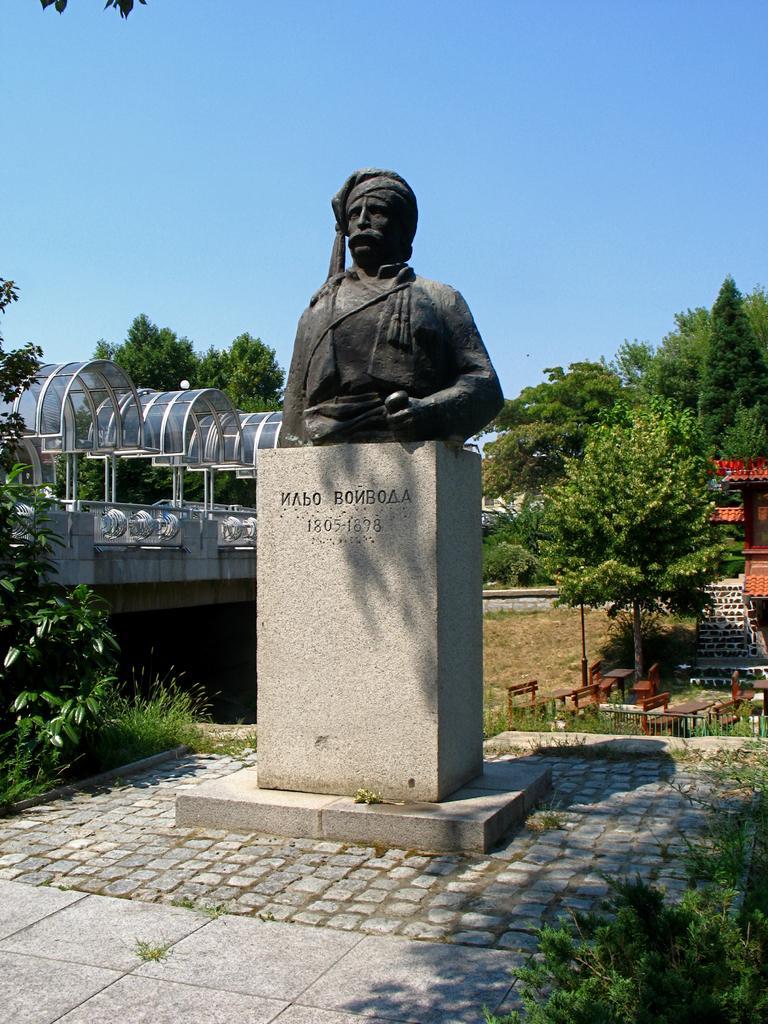Could you give a brief overview of what you see in this image? In this picture we can see a statue, in the background we can find few trees, benches, houses and a pole. 